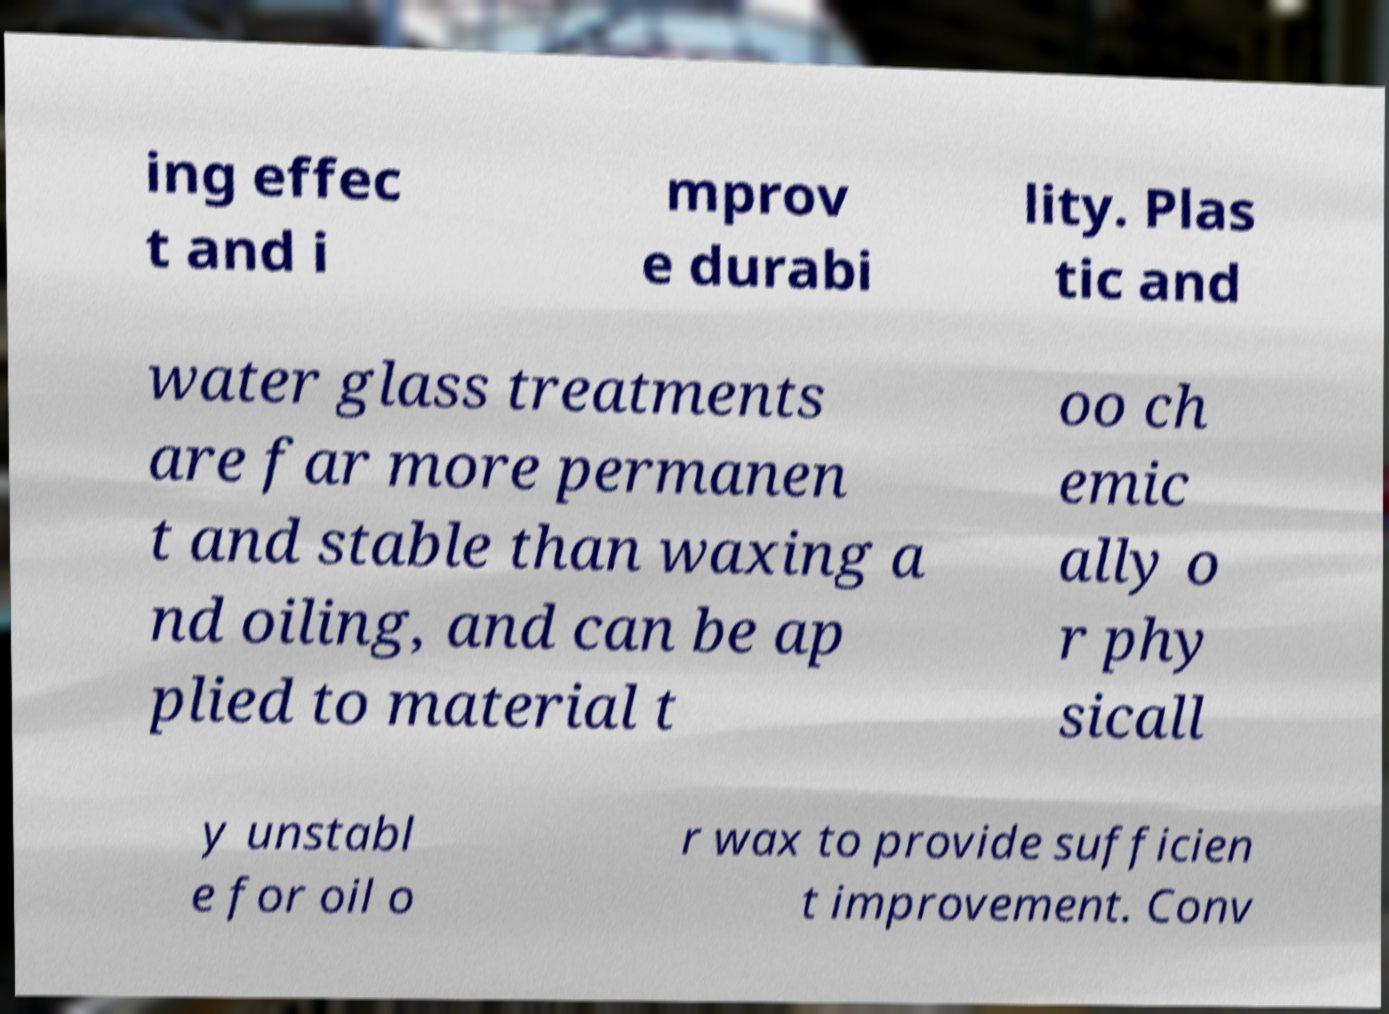Can you read and provide the text displayed in the image?This photo seems to have some interesting text. Can you extract and type it out for me? ing effec t and i mprov e durabi lity. Plas tic and water glass treatments are far more permanen t and stable than waxing a nd oiling, and can be ap plied to material t oo ch emic ally o r phy sicall y unstabl e for oil o r wax to provide sufficien t improvement. Conv 